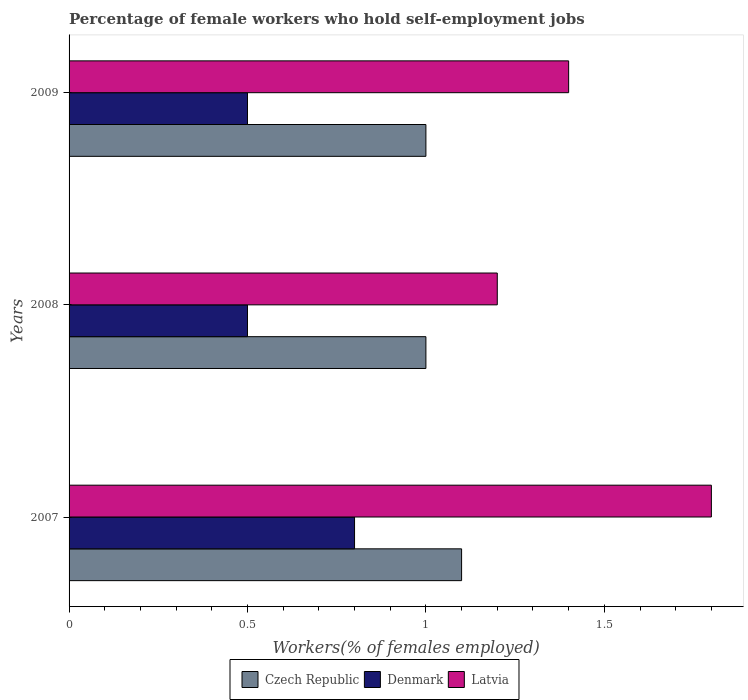Are the number of bars per tick equal to the number of legend labels?
Make the answer very short. Yes. How many bars are there on the 1st tick from the top?
Your answer should be compact. 3. Across all years, what is the maximum percentage of self-employed female workers in Latvia?
Provide a succinct answer. 1.8. In which year was the percentage of self-employed female workers in Denmark maximum?
Make the answer very short. 2007. What is the total percentage of self-employed female workers in Czech Republic in the graph?
Keep it short and to the point. 3.1. What is the difference between the percentage of self-employed female workers in Denmark in 2007 and that in 2008?
Give a very brief answer. 0.3. What is the difference between the percentage of self-employed female workers in Denmark in 2009 and the percentage of self-employed female workers in Latvia in 2007?
Keep it short and to the point. -1.3. What is the average percentage of self-employed female workers in Denmark per year?
Your response must be concise. 0.6. In the year 2007, what is the difference between the percentage of self-employed female workers in Denmark and percentage of self-employed female workers in Czech Republic?
Your answer should be compact. -0.3. In how many years, is the percentage of self-employed female workers in Latvia greater than 0.1 %?
Your response must be concise. 3. Is the percentage of self-employed female workers in Latvia in 2008 less than that in 2009?
Offer a terse response. Yes. Is the difference between the percentage of self-employed female workers in Denmark in 2007 and 2008 greater than the difference between the percentage of self-employed female workers in Czech Republic in 2007 and 2008?
Make the answer very short. Yes. What is the difference between the highest and the second highest percentage of self-employed female workers in Denmark?
Offer a very short reply. 0.3. What is the difference between the highest and the lowest percentage of self-employed female workers in Latvia?
Ensure brevity in your answer.  0.6. Is the sum of the percentage of self-employed female workers in Czech Republic in 2007 and 2008 greater than the maximum percentage of self-employed female workers in Denmark across all years?
Offer a terse response. Yes. What does the 1st bar from the top in 2008 represents?
Make the answer very short. Latvia. Is it the case that in every year, the sum of the percentage of self-employed female workers in Denmark and percentage of self-employed female workers in Czech Republic is greater than the percentage of self-employed female workers in Latvia?
Keep it short and to the point. Yes. How many years are there in the graph?
Keep it short and to the point. 3. Does the graph contain any zero values?
Offer a terse response. No. Does the graph contain grids?
Your answer should be very brief. No. Where does the legend appear in the graph?
Ensure brevity in your answer.  Bottom center. How many legend labels are there?
Offer a very short reply. 3. How are the legend labels stacked?
Ensure brevity in your answer.  Horizontal. What is the title of the graph?
Offer a very short reply. Percentage of female workers who hold self-employment jobs. Does "Macao" appear as one of the legend labels in the graph?
Offer a very short reply. No. What is the label or title of the X-axis?
Offer a very short reply. Workers(% of females employed). What is the label or title of the Y-axis?
Ensure brevity in your answer.  Years. What is the Workers(% of females employed) of Czech Republic in 2007?
Ensure brevity in your answer.  1.1. What is the Workers(% of females employed) in Denmark in 2007?
Offer a very short reply. 0.8. What is the Workers(% of females employed) in Latvia in 2007?
Offer a terse response. 1.8. What is the Workers(% of females employed) of Czech Republic in 2008?
Provide a short and direct response. 1. What is the Workers(% of females employed) in Latvia in 2008?
Ensure brevity in your answer.  1.2. What is the Workers(% of females employed) of Czech Republic in 2009?
Provide a short and direct response. 1. What is the Workers(% of females employed) of Latvia in 2009?
Provide a short and direct response. 1.4. Across all years, what is the maximum Workers(% of females employed) of Czech Republic?
Provide a succinct answer. 1.1. Across all years, what is the maximum Workers(% of females employed) of Denmark?
Offer a very short reply. 0.8. Across all years, what is the maximum Workers(% of females employed) of Latvia?
Your answer should be compact. 1.8. Across all years, what is the minimum Workers(% of females employed) in Denmark?
Your response must be concise. 0.5. Across all years, what is the minimum Workers(% of females employed) in Latvia?
Ensure brevity in your answer.  1.2. What is the total Workers(% of females employed) of Czech Republic in the graph?
Give a very brief answer. 3.1. What is the total Workers(% of females employed) in Latvia in the graph?
Your answer should be compact. 4.4. What is the difference between the Workers(% of females employed) of Latvia in 2007 and that in 2008?
Your answer should be very brief. 0.6. What is the difference between the Workers(% of females employed) of Czech Republic in 2007 and that in 2009?
Your response must be concise. 0.1. What is the difference between the Workers(% of females employed) of Latvia in 2007 and that in 2009?
Offer a very short reply. 0.4. What is the difference between the Workers(% of females employed) in Latvia in 2008 and that in 2009?
Provide a succinct answer. -0.2. What is the difference between the Workers(% of females employed) in Czech Republic in 2007 and the Workers(% of females employed) in Denmark in 2008?
Ensure brevity in your answer.  0.6. What is the difference between the Workers(% of females employed) of Denmark in 2007 and the Workers(% of females employed) of Latvia in 2008?
Give a very brief answer. -0.4. What is the difference between the Workers(% of females employed) of Czech Republic in 2007 and the Workers(% of females employed) of Latvia in 2009?
Offer a very short reply. -0.3. What is the difference between the Workers(% of females employed) of Denmark in 2007 and the Workers(% of females employed) of Latvia in 2009?
Provide a succinct answer. -0.6. What is the average Workers(% of females employed) in Latvia per year?
Your response must be concise. 1.47. In the year 2007, what is the difference between the Workers(% of females employed) of Denmark and Workers(% of females employed) of Latvia?
Make the answer very short. -1. In the year 2008, what is the difference between the Workers(% of females employed) of Czech Republic and Workers(% of females employed) of Latvia?
Your answer should be compact. -0.2. In the year 2008, what is the difference between the Workers(% of females employed) in Denmark and Workers(% of females employed) in Latvia?
Your response must be concise. -0.7. In the year 2009, what is the difference between the Workers(% of females employed) of Czech Republic and Workers(% of females employed) of Denmark?
Make the answer very short. 0.5. In the year 2009, what is the difference between the Workers(% of females employed) in Czech Republic and Workers(% of females employed) in Latvia?
Keep it short and to the point. -0.4. What is the ratio of the Workers(% of females employed) of Czech Republic in 2007 to that in 2008?
Your answer should be compact. 1.1. What is the ratio of the Workers(% of females employed) of Denmark in 2007 to that in 2008?
Provide a short and direct response. 1.6. What is the ratio of the Workers(% of females employed) of Latvia in 2007 to that in 2008?
Your answer should be compact. 1.5. What is the ratio of the Workers(% of females employed) in Czech Republic in 2007 to that in 2009?
Keep it short and to the point. 1.1. What is the ratio of the Workers(% of females employed) of Czech Republic in 2008 to that in 2009?
Provide a succinct answer. 1. What is the ratio of the Workers(% of females employed) in Denmark in 2008 to that in 2009?
Your response must be concise. 1. What is the ratio of the Workers(% of females employed) in Latvia in 2008 to that in 2009?
Your answer should be compact. 0.86. What is the difference between the highest and the second highest Workers(% of females employed) in Czech Republic?
Provide a short and direct response. 0.1. What is the difference between the highest and the second highest Workers(% of females employed) of Denmark?
Provide a short and direct response. 0.3. What is the difference between the highest and the second highest Workers(% of females employed) in Latvia?
Keep it short and to the point. 0.4. What is the difference between the highest and the lowest Workers(% of females employed) of Czech Republic?
Make the answer very short. 0.1. What is the difference between the highest and the lowest Workers(% of females employed) in Latvia?
Your answer should be compact. 0.6. 